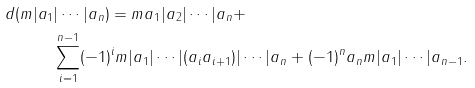Convert formula to latex. <formula><loc_0><loc_0><loc_500><loc_500>d ( m | a _ { 1 } & | \cdots | a _ { n } ) = m a _ { 1 } | a _ { 2 } | \cdots | a _ { n } + \\ & \sum _ { i = 1 } ^ { n - 1 } ( - 1 ) ^ { i } m | a _ { 1 } | \cdots | ( a _ { i } a _ { i + 1 } ) | \cdots | a _ { n } + ( - 1 ) ^ { n } a _ { n } m | a _ { 1 } | \cdots | a _ { n - 1 } .</formula> 